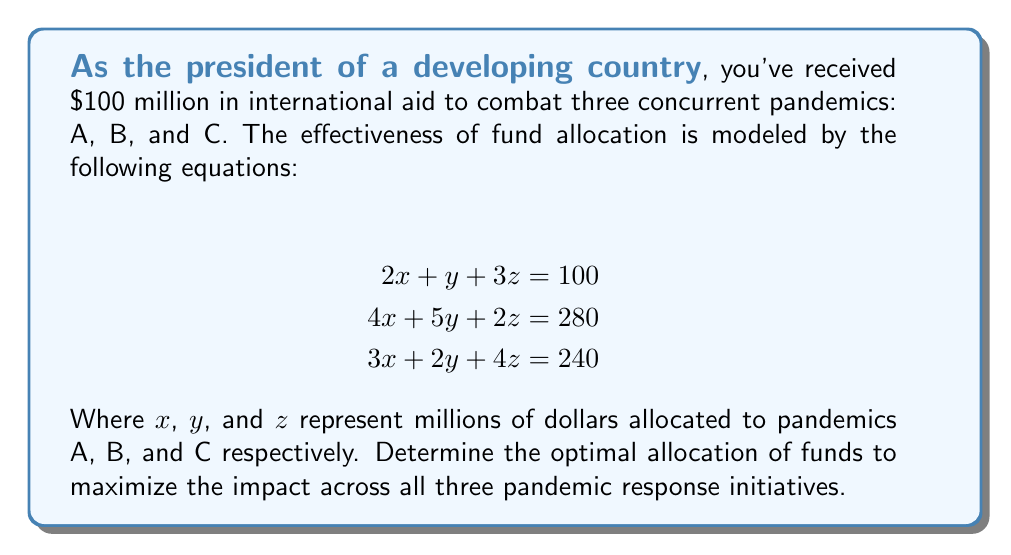Solve this math problem. To solve this system of equations, we'll use the elimination method:

1) Multiply the first equation by 2:
   $$4x + 2y + 6z = 200$$

2) Subtract this from the second equation:
   $$(4x + 5y + 2z) - (4x + 2y + 6z) = 280 - 200$$
   $$3y - 4z = 80 \quad \text{(Equation 4)}$$

3) Multiply the first equation by 3:
   $$6x + 3y + 9z = 300$$

4) Subtract this from the third equation:
   $$(3x + 2y + 4z) - (6x + 3y + 9z) = 240 - 300$$
   $$-3x - y - 5z = -60$$
   $$3x + y + 5z = 60 \quad \text{(Equation 5)}$$

5) Multiply Equation 4 by 5 and Equation 5 by 3:
   $$15y - 20z = 400$$
   $$9x + 3y + 15z = 180$$

6) Add these equations:
   $$9x + 18y - 5z = 580$$

7) Multiply the first original equation by 9:
   $$18x + 9y + 27z = 900$$

8) Subtract this from the equation in step 6:
   $$(9x + 18y - 5z) - (18x + 9y + 27z) = 580 - 900$$
   $$9y - 32z = -320$$
   $$9y = 32z - 320$$
   $$y = \frac{32z - 320}{9}$$

9) Substitute this into Equation 4:
   $$3(\frac{32z - 320}{9}) - 4z = 80$$
   $$\frac{96z - 960}{9} - 4z = 80$$
   $$96z - 960 - 36z = 720$$
   $$60z = 1680$$
   $$z = 28$$

10) Substitute $z = 28$ into the equation for $y$:
    $$y = \frac{32(28) - 320}{9} = \frac{576}{9} = 64$$

11) Substitute $y = 64$ and $z = 28$ into the first original equation:
    $$2x + 64 + 3(28) = 100$$
    $$2x = 100 - 64 - 84 = -48$$
    $$x = -24$$

Therefore, the optimal allocation is:
$x = -24$, $y = 64$, $z = 28$

However, since negative funding isn't possible, we need to adjust our interpretation. The negative value for $x$ suggests that pandemic A doesn't require additional funding from this aid package.
Answer: The optimal allocation of the $100 million aid package is:
Pandemic A: $0 million
Pandemic B: $64 million
Pandemic C: $28 million
The remaining $8 million should be held in reserve or redistributed based on emerging needs. 